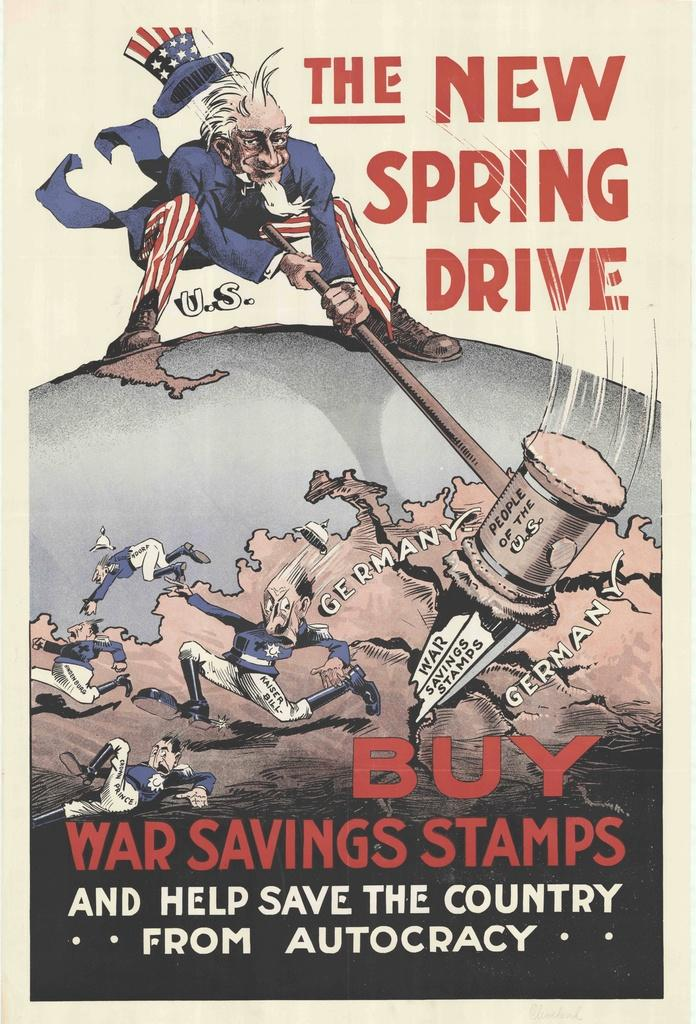<image>
Summarize the visual content of the image. Uncle Sam swings a hammer in an advertisement for the new Spring Drive. 